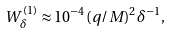<formula> <loc_0><loc_0><loc_500><loc_500>W _ { \delta } ^ { ( 1 ) } \approx 1 0 ^ { - 4 } ( q / M ) ^ { 2 } \delta ^ { - 1 } ,</formula> 